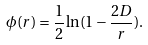<formula> <loc_0><loc_0><loc_500><loc_500>\phi ( r ) = \frac { 1 } { 2 } \ln ( 1 - \frac { 2 D } { r } ) .</formula> 